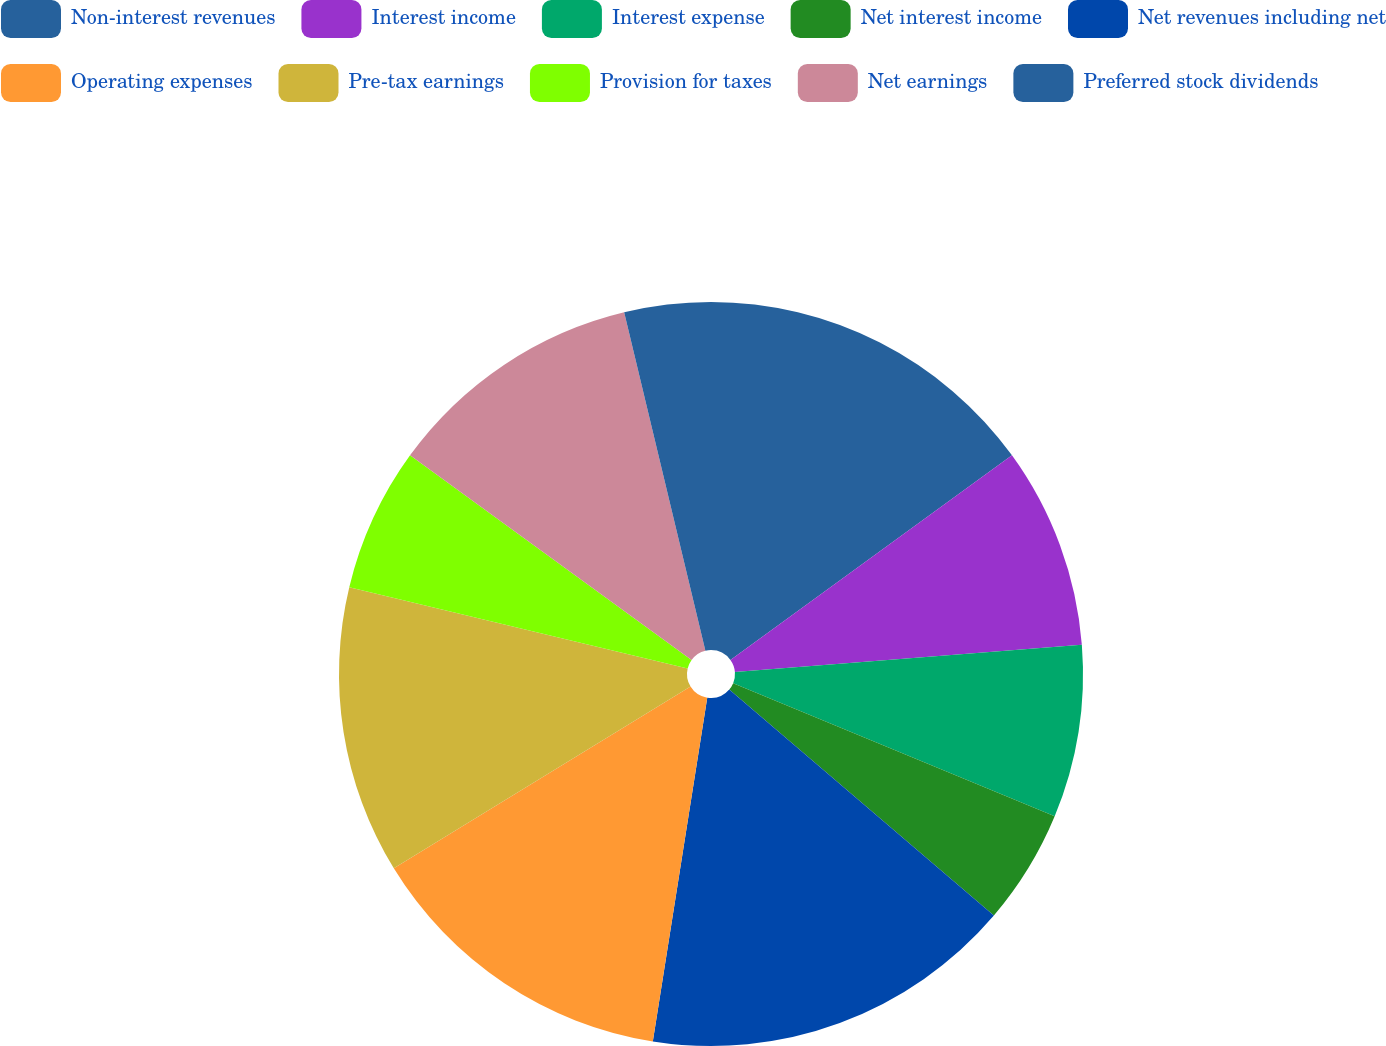Convert chart. <chart><loc_0><loc_0><loc_500><loc_500><pie_chart><fcel>Non-interest revenues<fcel>Interest income<fcel>Interest expense<fcel>Net interest income<fcel>Net revenues including net<fcel>Operating expenses<fcel>Pre-tax earnings<fcel>Provision for taxes<fcel>Net earnings<fcel>Preferred stock dividends<nl><fcel>15.0%<fcel>8.75%<fcel>7.5%<fcel>5.0%<fcel>16.25%<fcel>13.75%<fcel>12.5%<fcel>6.25%<fcel>11.25%<fcel>3.75%<nl></chart> 